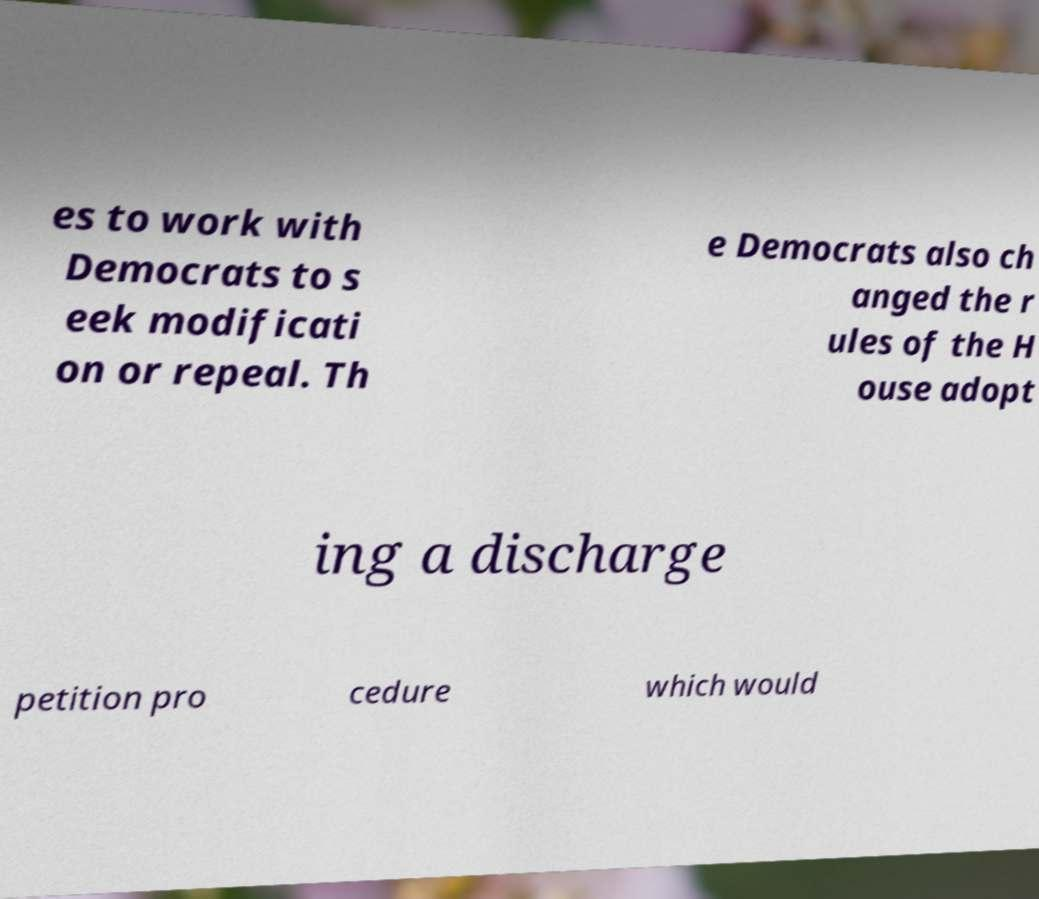Please read and relay the text visible in this image. What does it say? es to work with Democrats to s eek modificati on or repeal. Th e Democrats also ch anged the r ules of the H ouse adopt ing a discharge petition pro cedure which would 